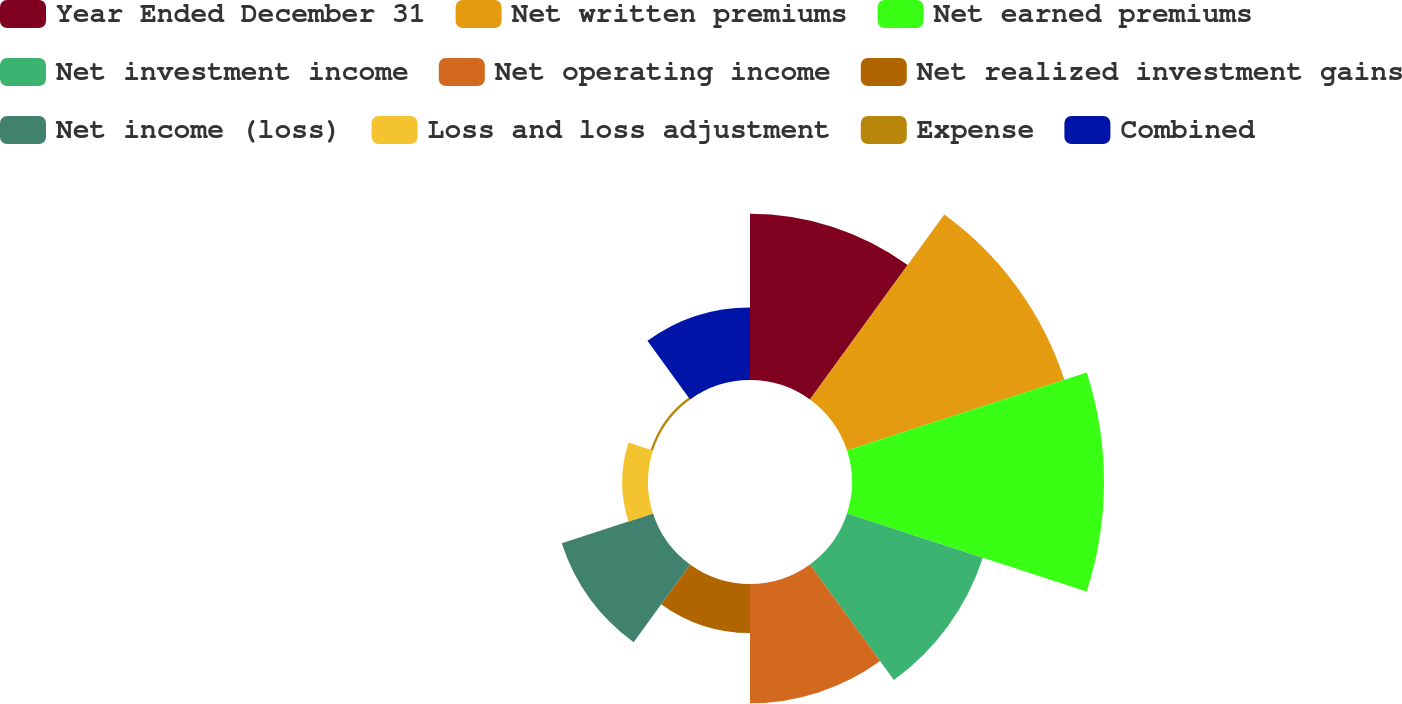Convert chart to OTSL. <chart><loc_0><loc_0><loc_500><loc_500><pie_chart><fcel>Year Ended December 31<fcel>Net written premiums<fcel>Net earned premiums<fcel>Net investment income<fcel>Net operating income<fcel>Net realized investment gains<fcel>Net income (loss)<fcel>Loss and loss adjustment<fcel>Expense<fcel>Combined<nl><fcel>14.4%<fcel>19.8%<fcel>21.83%<fcel>12.37%<fcel>10.34%<fcel>4.25%<fcel>8.31%<fcel>2.23%<fcel>0.2%<fcel>6.28%<nl></chart> 